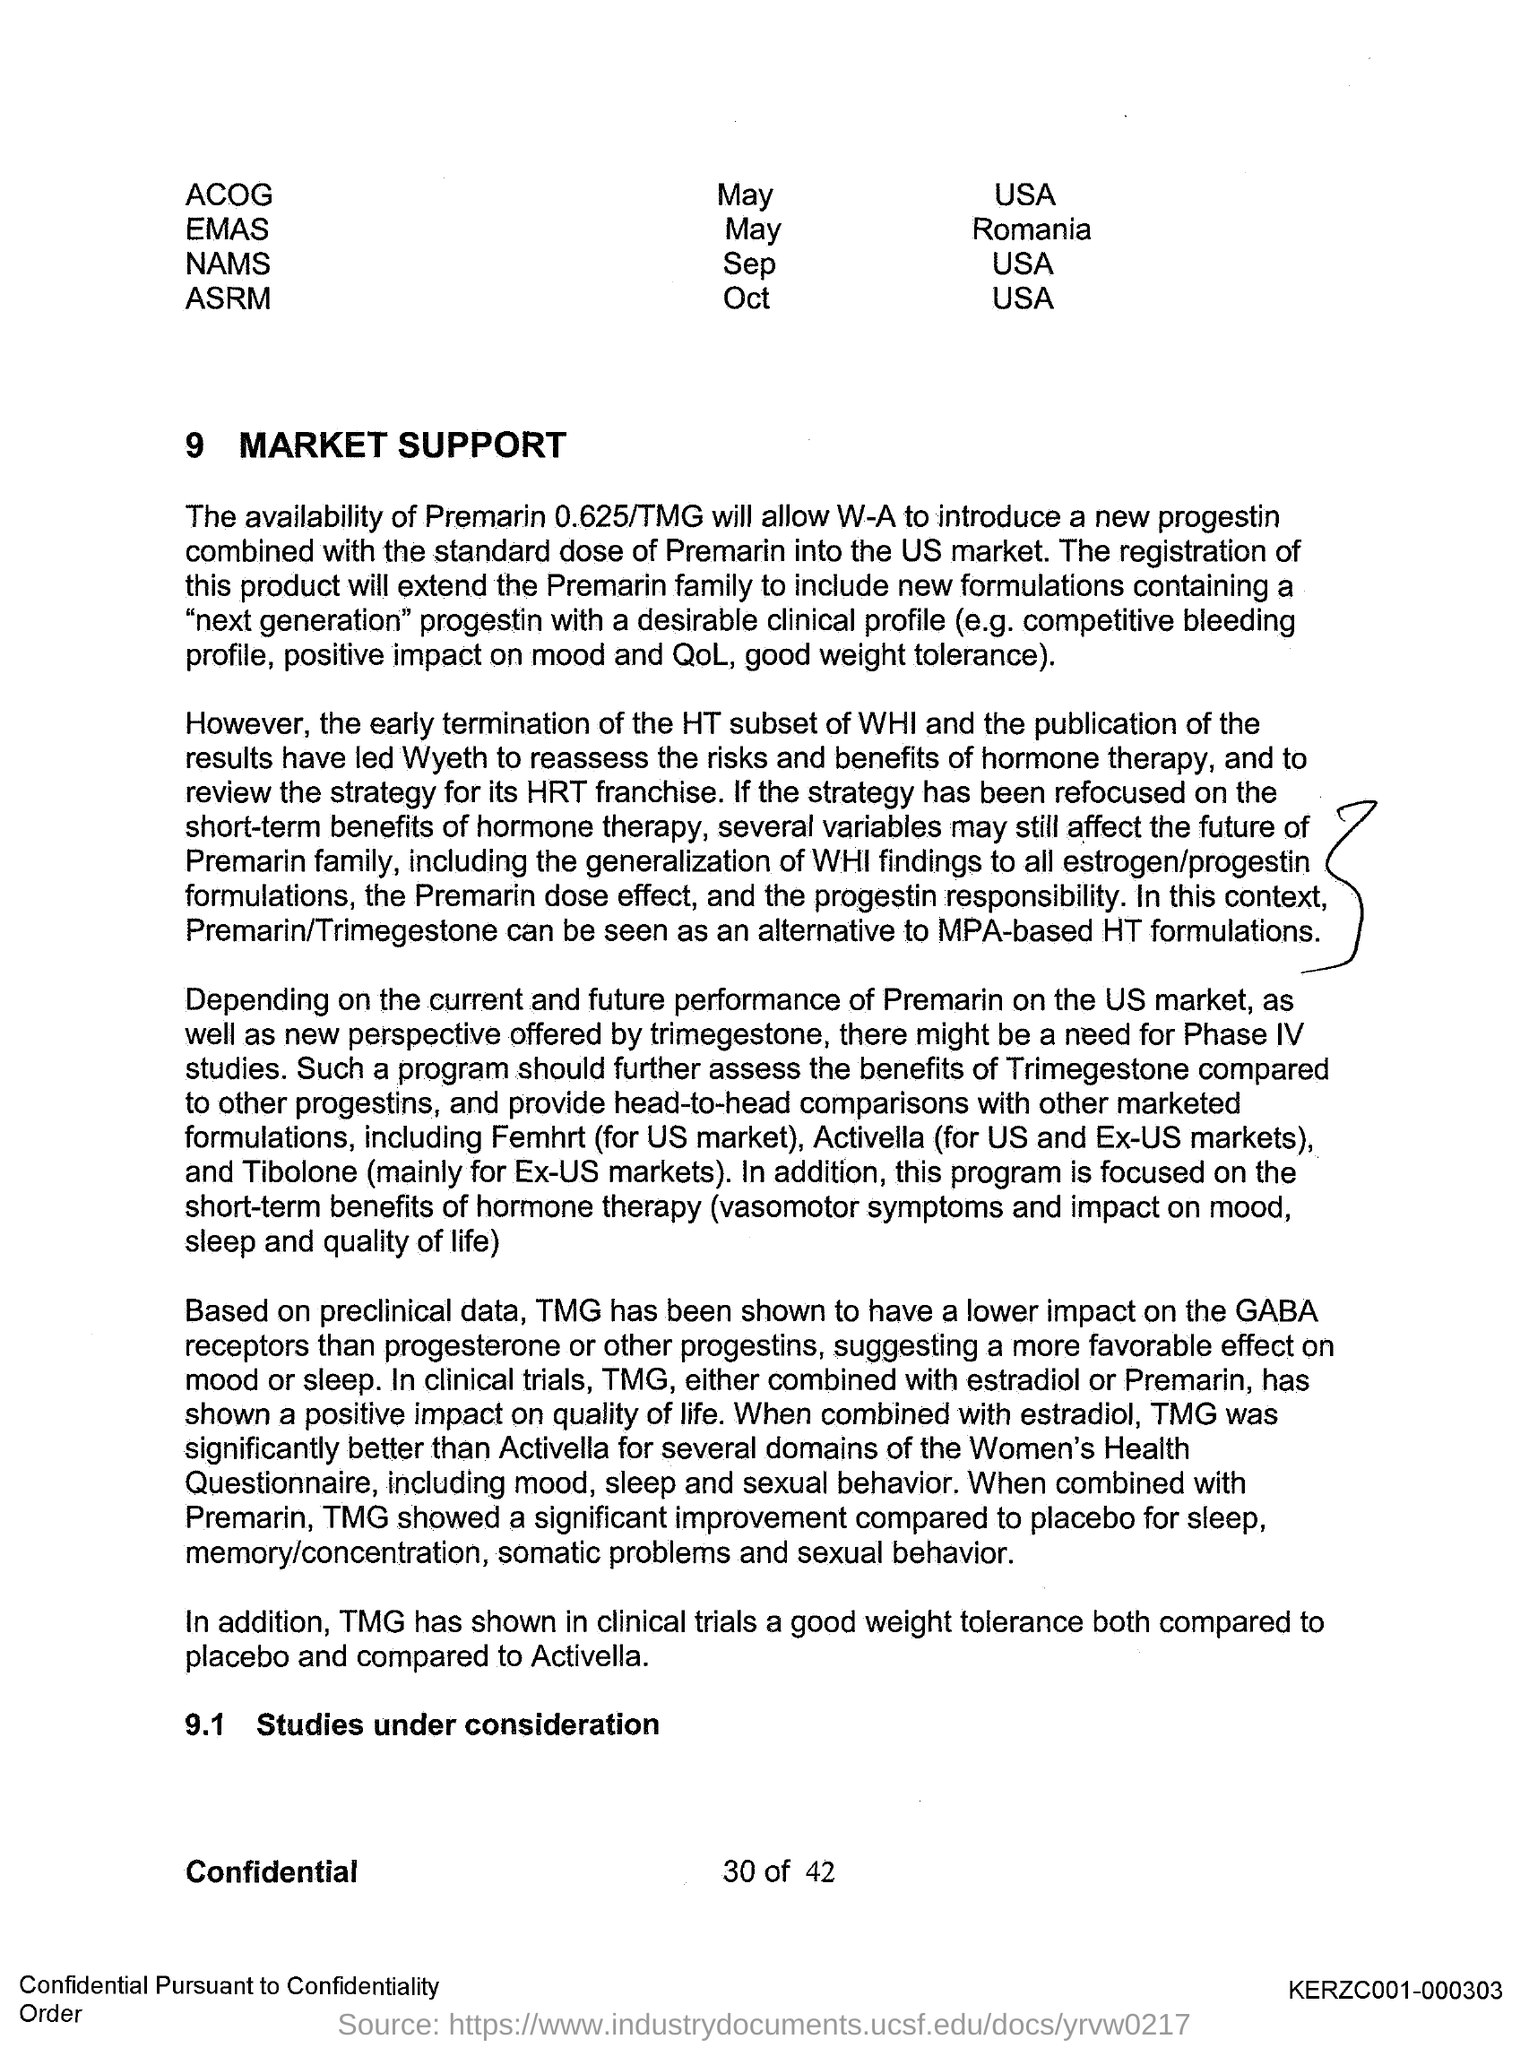Highlight a few significant elements in this photo. The second title in the document is 9.1 Studies under consideration. Market Support is the first title in the document. 